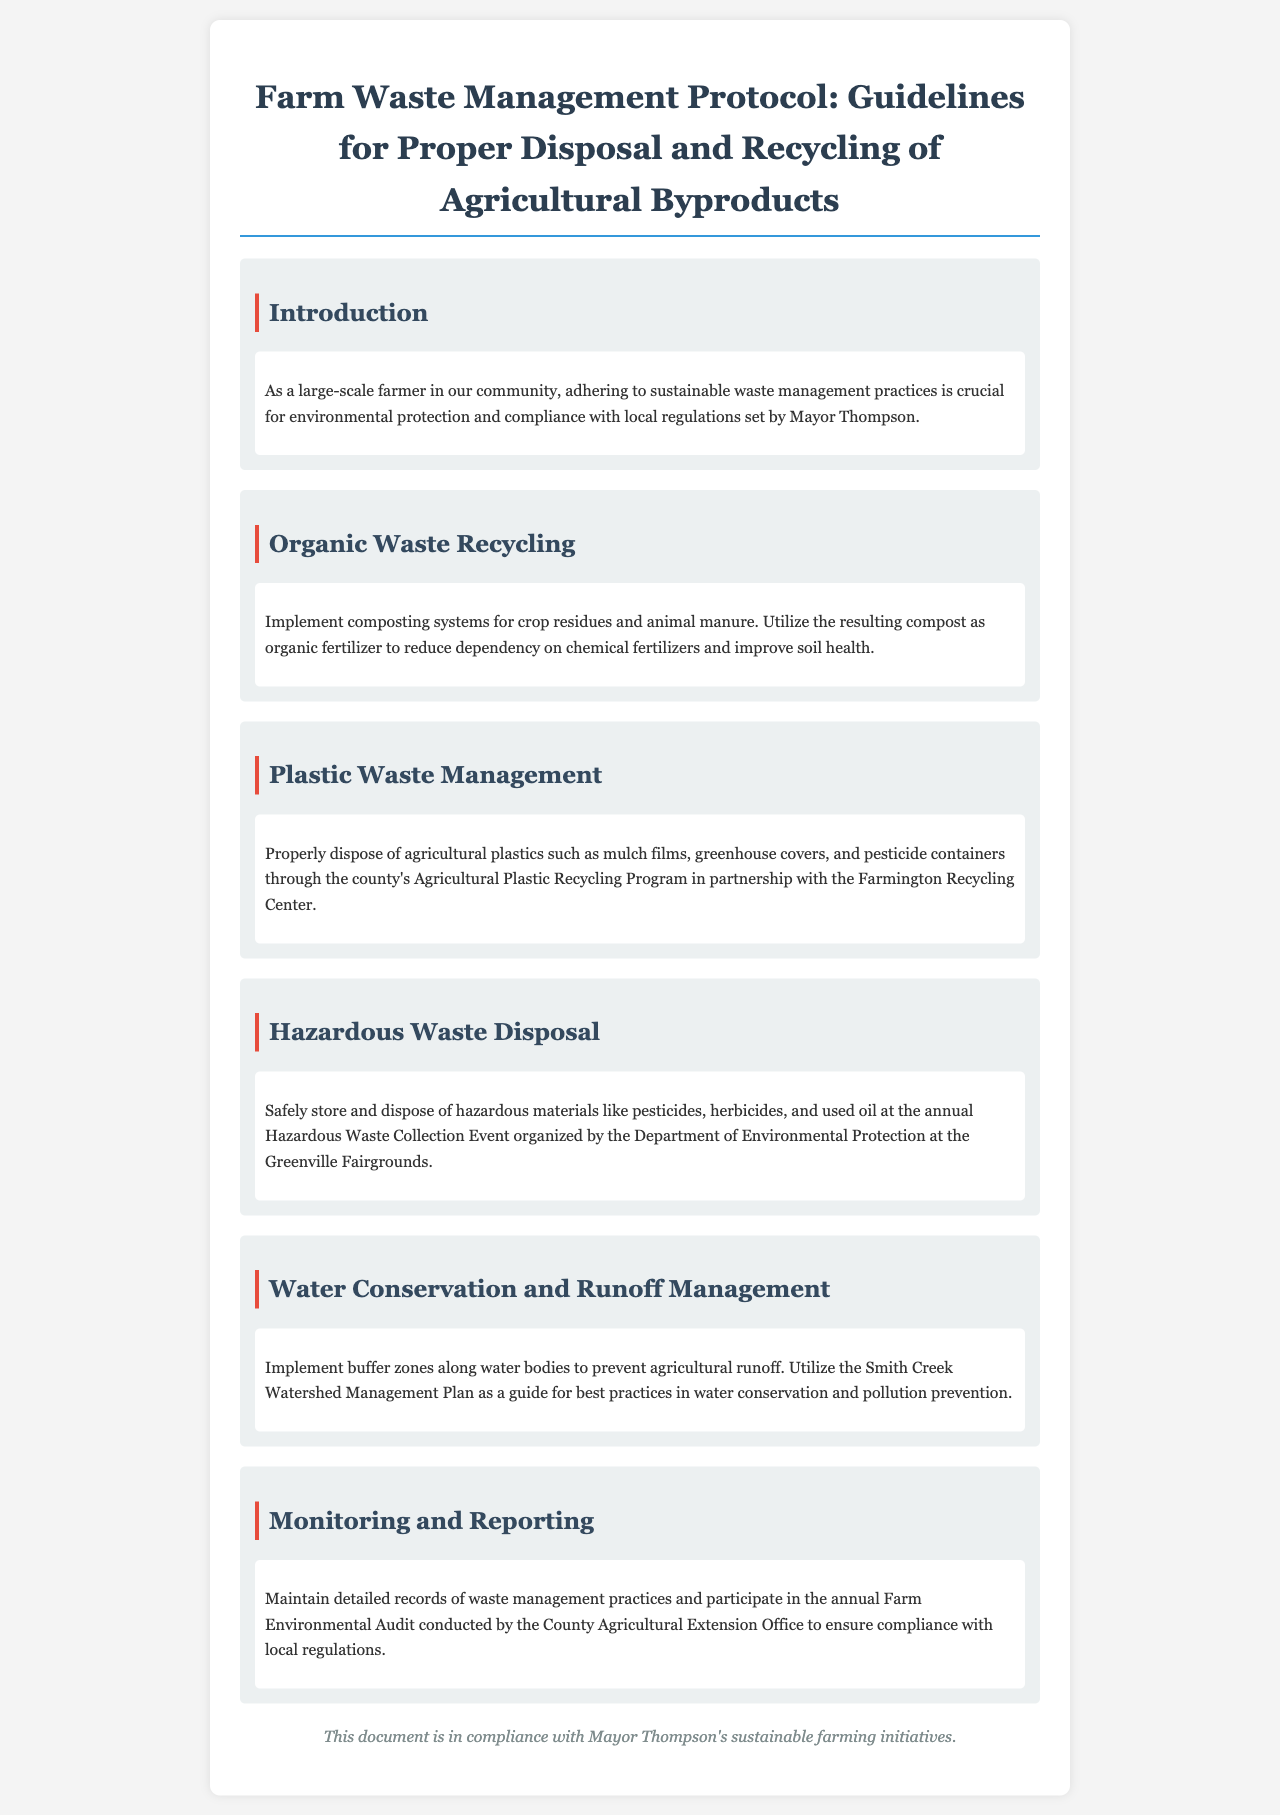What is the title of the document? The title of the document is stated at the top of the rendered output as "Farm Waste Management Protocol: Guidelines for Proper Disposal and Recycling of Agricultural Byproducts."
Answer: Farm Waste Management Protocol: Guidelines for Proper Disposal and Recycling of Agricultural Byproducts Who organized the Hazardous Waste Collection Event? The Hazardous Waste Collection Event is organized by the Department of Environmental Protection.
Answer: Department of Environmental Protection What should be used as organic fertilizer? The resulting compost from the composting systems should be used as organic fertilizer.
Answer: Compost What is one of the recommended methods for recycling organic waste? Implementing composting systems for crop residues and animal manure is a recommended method for recycling organic waste.
Answer: Composting systems What are buffer zones used for? Buffer zones are implemented along water bodies to prevent agricultural runoff.
Answer: Prevent agricultural runoff What action should be taken for agricultural plastics? Agricultural plastics should be disposed of through the county's Agricultural Plastic Recycling Program.
Answer: Agricultural Plastic Recycling Program What type of audit should farmers participate in annually? Farmers should participate in the annual Farm Environmental Audit.
Answer: Farm Environmental Audit Which watershed management plan is mentioned? The Smith Creek Watershed Management Plan is mentioned as a guide for best practices.
Answer: Smith Creek Watershed Management Plan What is the purpose of maintaining detailed records? Maintaining detailed records ensures compliance with local regulations.
Answer: Ensure compliance with local regulations 